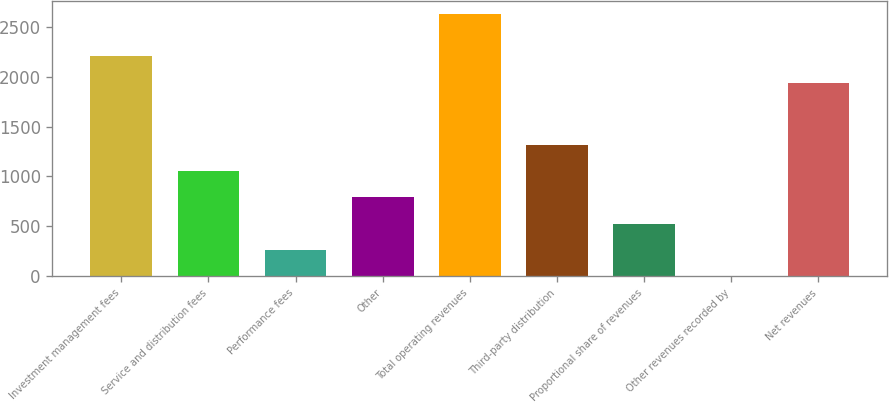Convert chart to OTSL. <chart><loc_0><loc_0><loc_500><loc_500><bar_chart><fcel>Investment management fees<fcel>Service and distribution fees<fcel>Performance fees<fcel>Other<fcel>Total operating revenues<fcel>Third-party distribution<fcel>Proportional share of revenues<fcel>Other revenues recorded by<fcel>Net revenues<nl><fcel>2203.53<fcel>1052.12<fcel>264.53<fcel>789.59<fcel>2627.3<fcel>1314.65<fcel>527.06<fcel>2<fcel>1941<nl></chart> 